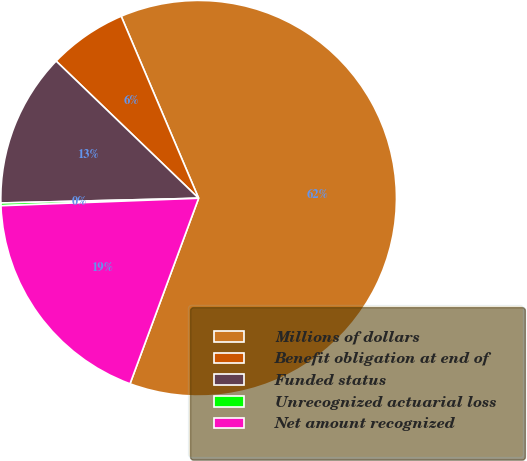Convert chart to OTSL. <chart><loc_0><loc_0><loc_500><loc_500><pie_chart><fcel>Millions of dollars<fcel>Benefit obligation at end of<fcel>Funded status<fcel>Unrecognized actuarial loss<fcel>Net amount recognized<nl><fcel>62.04%<fcel>6.4%<fcel>12.58%<fcel>0.22%<fcel>18.76%<nl></chart> 